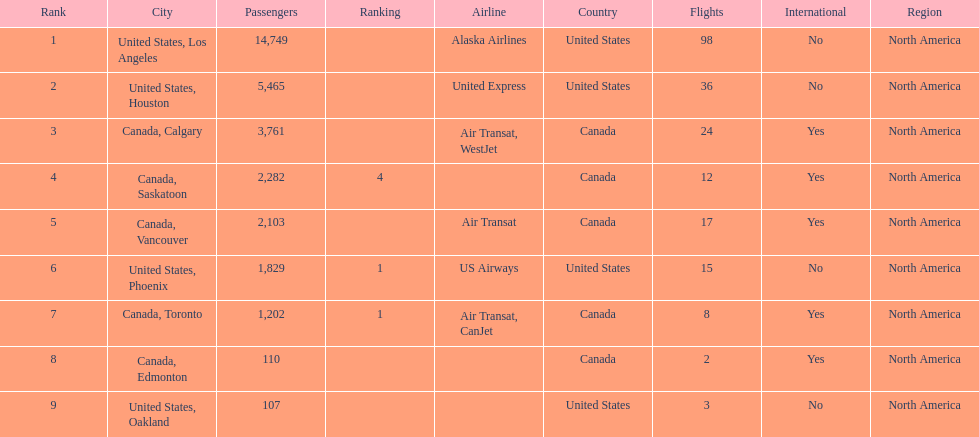The difference in passengers between los angeles and toronto 13,547. 